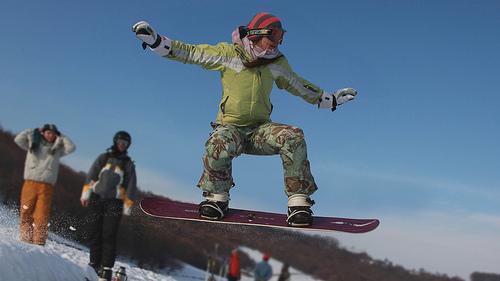How many people are pictured?
Give a very brief answer. 6. 